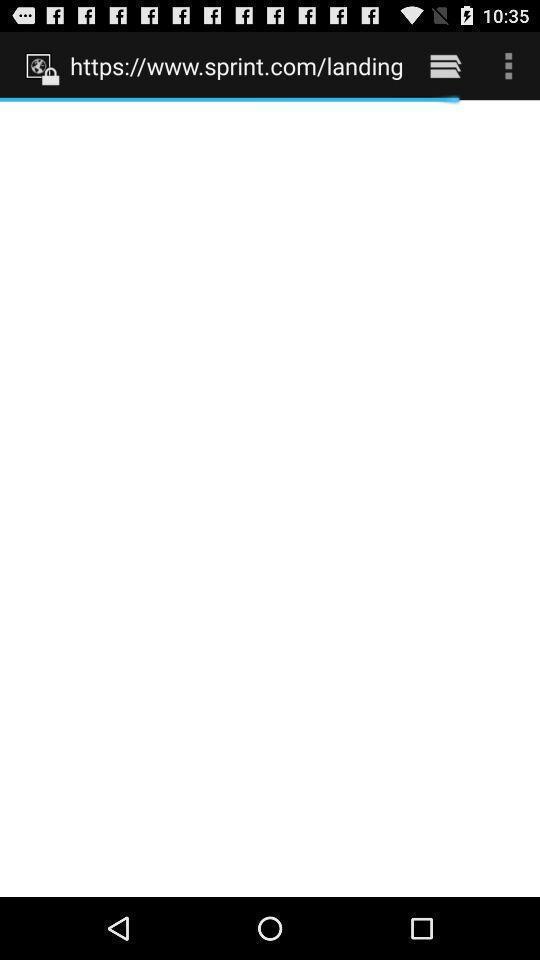Explain the elements present in this screenshot. Web site of the page is opening. 